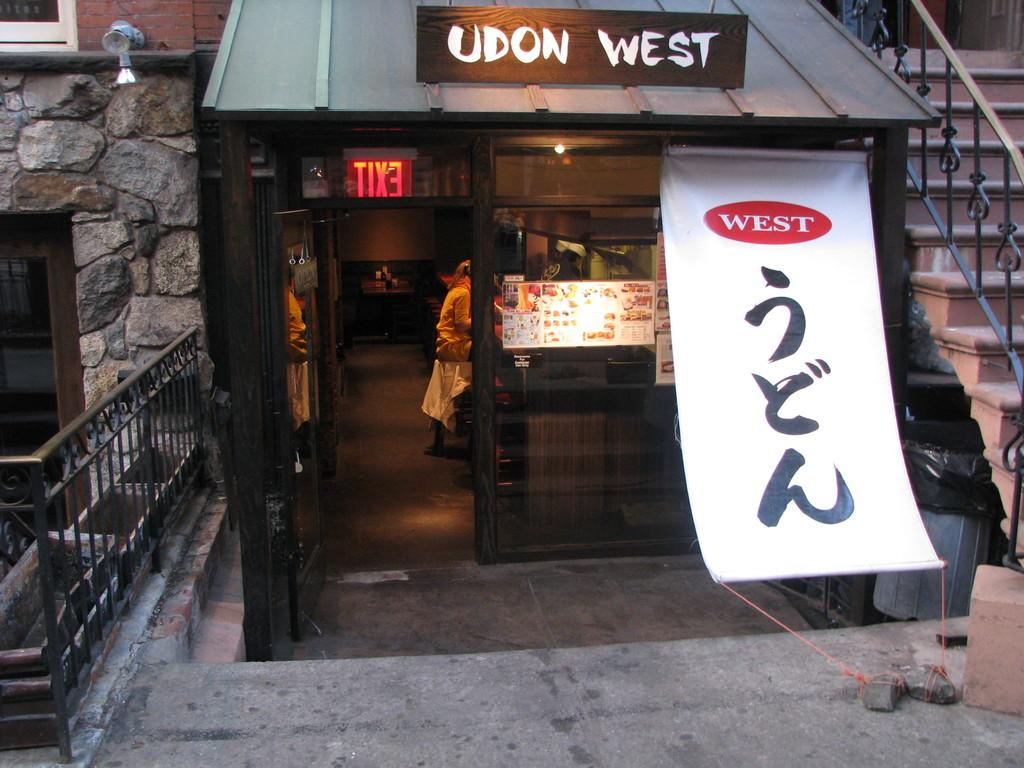<image>
Create a compact narrative representing the image presented. A small restaurant front with an Udon West sign atop it. 